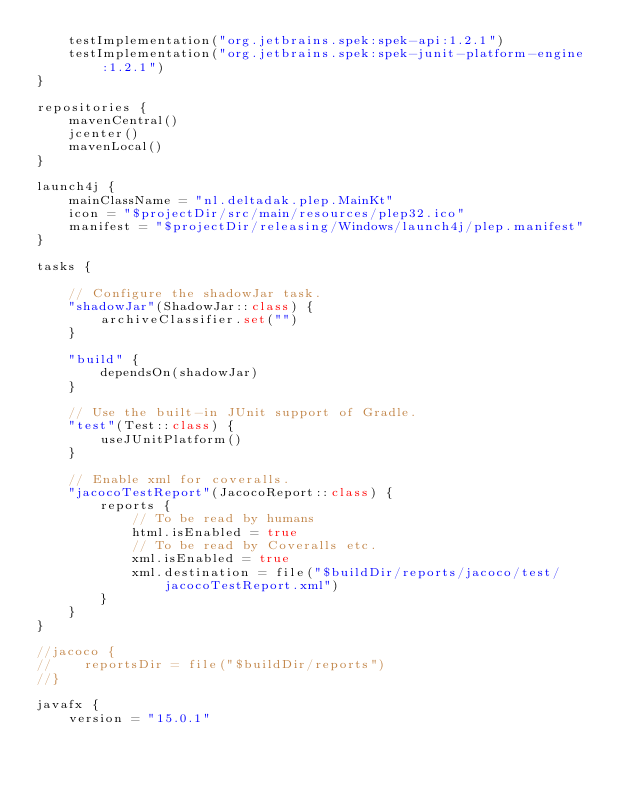<code> <loc_0><loc_0><loc_500><loc_500><_Kotlin_>    testImplementation("org.jetbrains.spek:spek-api:1.2.1")
    testImplementation("org.jetbrains.spek:spek-junit-platform-engine:1.2.1")
}

repositories {
    mavenCentral()
    jcenter()
    mavenLocal()
}

launch4j {
    mainClassName = "nl.deltadak.plep.MainKt"
    icon = "$projectDir/src/main/resources/plep32.ico"
    manifest = "$projectDir/releasing/Windows/launch4j/plep.manifest"
}

tasks {

    // Configure the shadowJar task.
    "shadowJar"(ShadowJar::class) {
        archiveClassifier.set("")
    }

    "build" {
        dependsOn(shadowJar)
    }

    // Use the built-in JUnit support of Gradle.
    "test"(Test::class) {
        useJUnitPlatform()
    }

    // Enable xml for coveralls.
    "jacocoTestReport"(JacocoReport::class) {
        reports {
            // To be read by humans
            html.isEnabled = true
            // To be read by Coveralls etc.
            xml.isEnabled = true
            xml.destination = file("$buildDir/reports/jacoco/test/jacocoTestReport.xml")
        }
    }
}

//jacoco {
//    reportsDir = file("$buildDir/reports")
//}

javafx {
    version = "15.0.1"</code> 